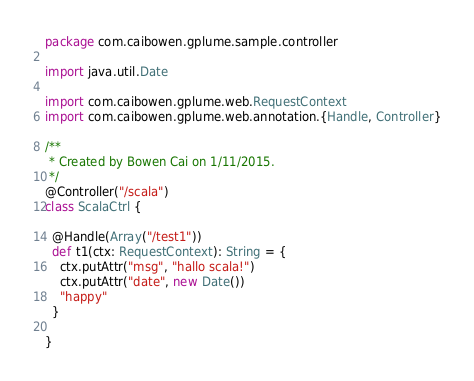<code> <loc_0><loc_0><loc_500><loc_500><_Scala_>package com.caibowen.gplume.sample.controller

import java.util.Date

import com.caibowen.gplume.web.RequestContext
import com.caibowen.gplume.web.annotation.{Handle, Controller}

/**
 * Created by Bowen Cai on 1/11/2015.
 */
@Controller("/scala")
class ScalaCtrl {

  @Handle(Array("/test1"))
  def t1(ctx: RequestContext): String = {
    ctx.putAttr("msg", "hallo scala!")
    ctx.putAttr("date", new Date())
    "happy"
  }

}
</code> 